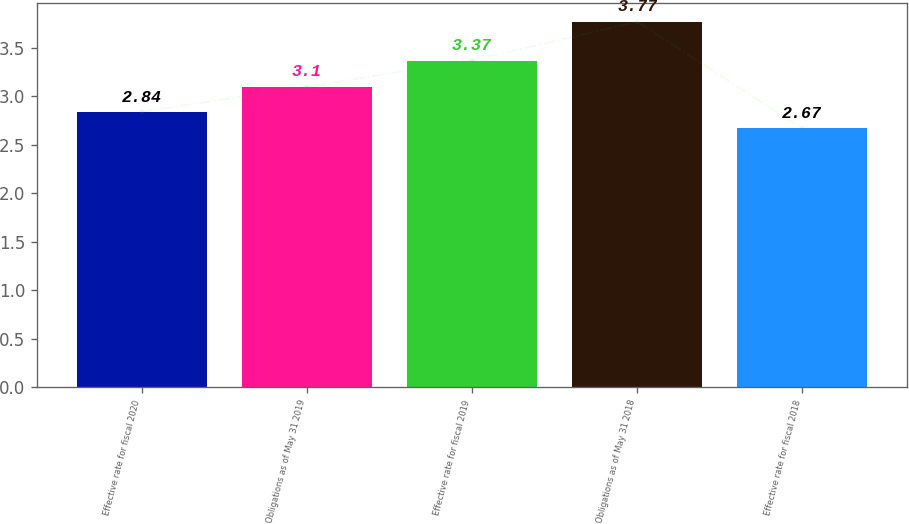Convert chart. <chart><loc_0><loc_0><loc_500><loc_500><bar_chart><fcel>Effective rate for fiscal 2020<fcel>Obligations as of May 31 2019<fcel>Effective rate for fiscal 2019<fcel>Obligations as of May 31 2018<fcel>Effective rate for fiscal 2018<nl><fcel>2.84<fcel>3.1<fcel>3.37<fcel>3.77<fcel>2.67<nl></chart> 